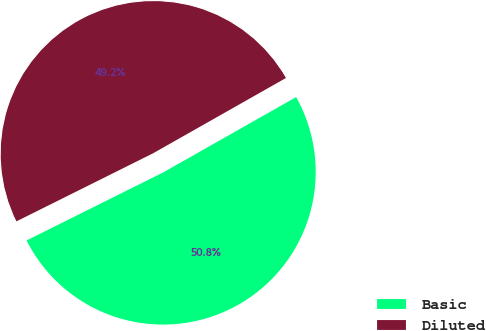<chart> <loc_0><loc_0><loc_500><loc_500><pie_chart><fcel>Basic<fcel>Diluted<nl><fcel>50.85%<fcel>49.15%<nl></chart> 